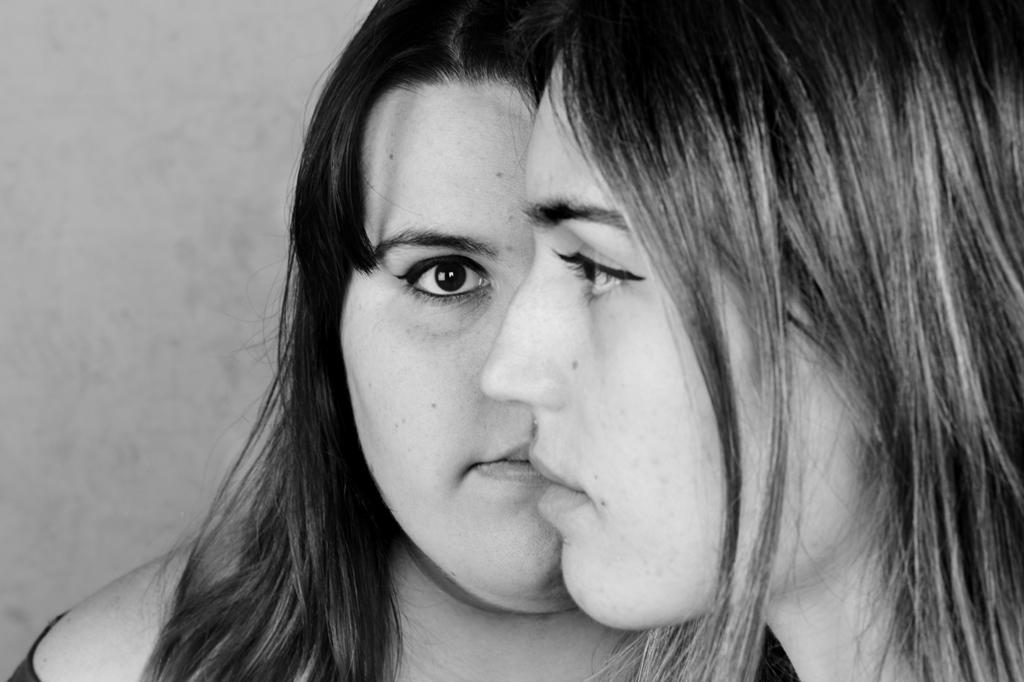How many people are in the image? There are two girls in the image. Where are the girls located in the image? The girls are in the center of the image. What type of boat can be seen in the image? There is no boat present in the image; it features two girls in the center. What activity are the girls participating in on the spot? The image does not show the girls participating in any specific activity, nor does it indicate a particular spot where they might be. 